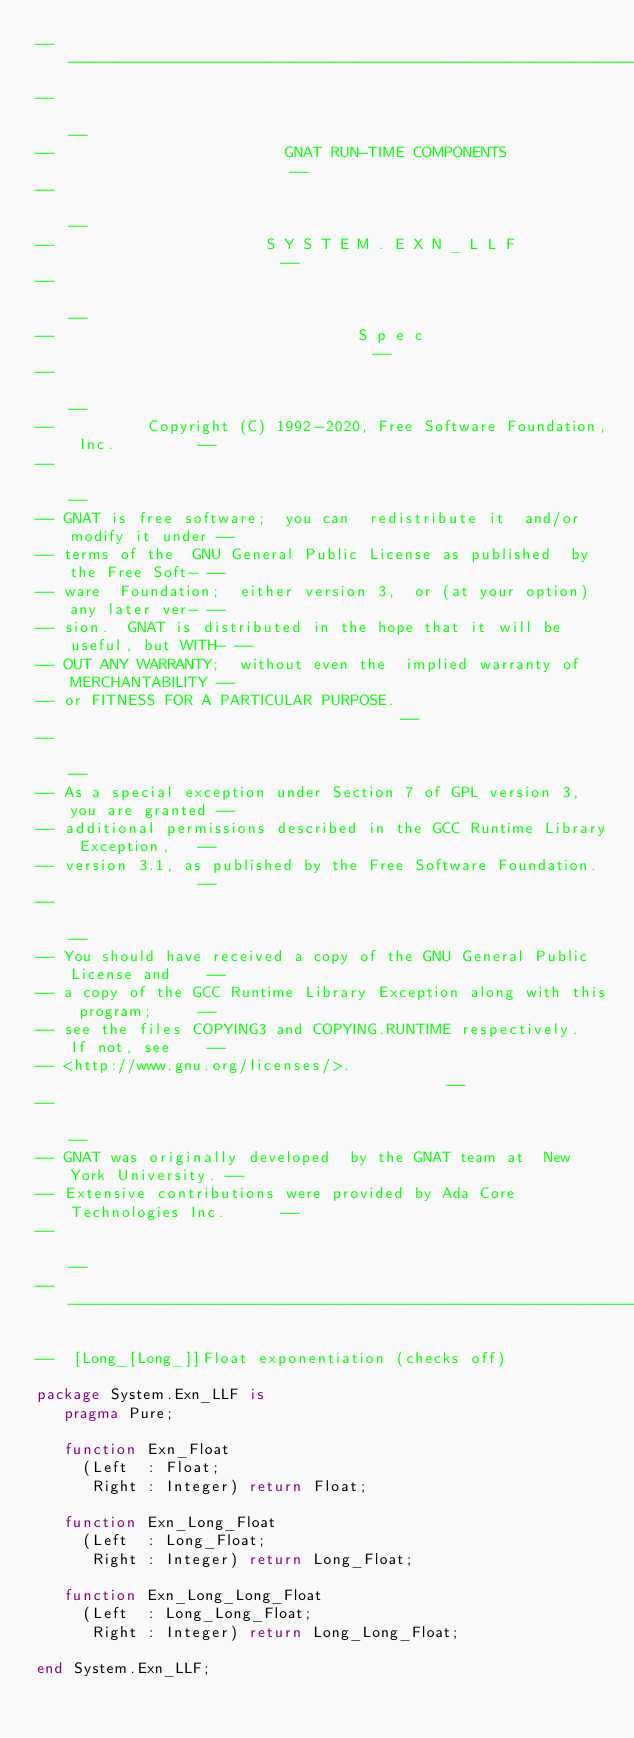<code> <loc_0><loc_0><loc_500><loc_500><_Ada_>------------------------------------------------------------------------------
--                                                                          --
--                         GNAT RUN-TIME COMPONENTS                         --
--                                                                          --
--                       S Y S T E M . E X N _ L L F                        --
--                                                                          --
--                                 S p e c                                  --
--                                                                          --
--          Copyright (C) 1992-2020, Free Software Foundation, Inc.         --
--                                                                          --
-- GNAT is free software;  you can  redistribute it  and/or modify it under --
-- terms of the  GNU General Public License as published  by the Free Soft- --
-- ware  Foundation;  either version 3,  or (at your option) any later ver- --
-- sion.  GNAT is distributed in the hope that it will be useful, but WITH- --
-- OUT ANY WARRANTY;  without even the  implied warranty of MERCHANTABILITY --
-- or FITNESS FOR A PARTICULAR PURPOSE.                                     --
--                                                                          --
-- As a special exception under Section 7 of GPL version 3, you are granted --
-- additional permissions described in the GCC Runtime Library Exception,   --
-- version 3.1, as published by the Free Software Foundation.               --
--                                                                          --
-- You should have received a copy of the GNU General Public License and    --
-- a copy of the GCC Runtime Library Exception along with this program;     --
-- see the files COPYING3 and COPYING.RUNTIME respectively.  If not, see    --
-- <http://www.gnu.org/licenses/>.                                          --
--                                                                          --
-- GNAT was originally developed  by the GNAT team at  New York University. --
-- Extensive contributions were provided by Ada Core Technologies Inc.      --
--                                                                          --
------------------------------------------------------------------------------

--  [Long_[Long_]]Float exponentiation (checks off)

package System.Exn_LLF is
   pragma Pure;

   function Exn_Float
     (Left  : Float;
      Right : Integer) return Float;

   function Exn_Long_Float
     (Left  : Long_Float;
      Right : Integer) return Long_Float;

   function Exn_Long_Long_Float
     (Left  : Long_Long_Float;
      Right : Integer) return Long_Long_Float;

end System.Exn_LLF;
</code> 